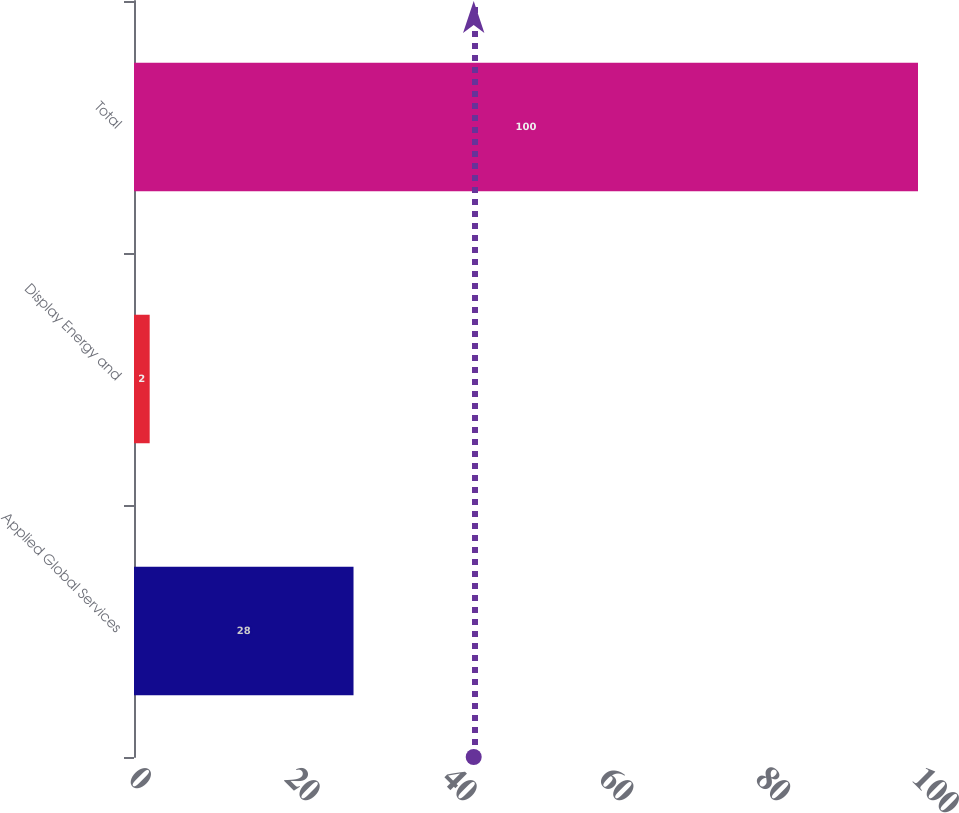<chart> <loc_0><loc_0><loc_500><loc_500><bar_chart><fcel>Applied Global Services<fcel>Display Energy and<fcel>Total<nl><fcel>28<fcel>2<fcel>100<nl></chart> 